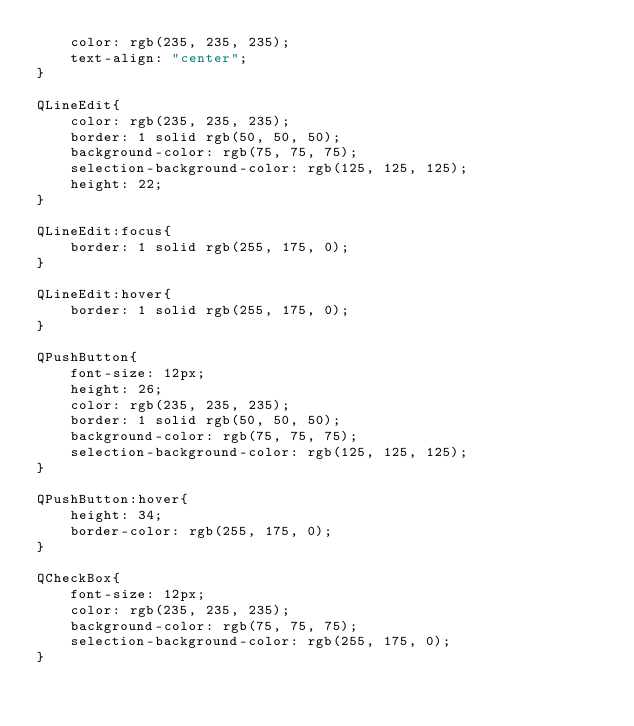<code> <loc_0><loc_0><loc_500><loc_500><_CSS_>    color: rgb(235, 235, 235);
    text-align: "center";
}

QLineEdit{
    color: rgb(235, 235, 235);
    border: 1 solid rgb(50, 50, 50);
    background-color: rgb(75, 75, 75);
    selection-background-color: rgb(125, 125, 125);
    height: 22;
}

QLineEdit:focus{
    border: 1 solid rgb(255, 175, 0);
}

QLineEdit:hover{
    border: 1 solid rgb(255, 175, 0);
}

QPushButton{
    font-size: 12px;
    height: 26;
    color: rgb(235, 235, 235);
    border: 1 solid rgb(50, 50, 50);
    background-color: rgb(75, 75, 75);
    selection-background-color: rgb(125, 125, 125);
}

QPushButton:hover{
    height: 34;
    border-color: rgb(255, 175, 0);
}

QCheckBox{
    font-size: 12px;
    color: rgb(235, 235, 235);
    background-color: rgb(75, 75, 75);
    selection-background-color: rgb(255, 175, 0);
}</code> 